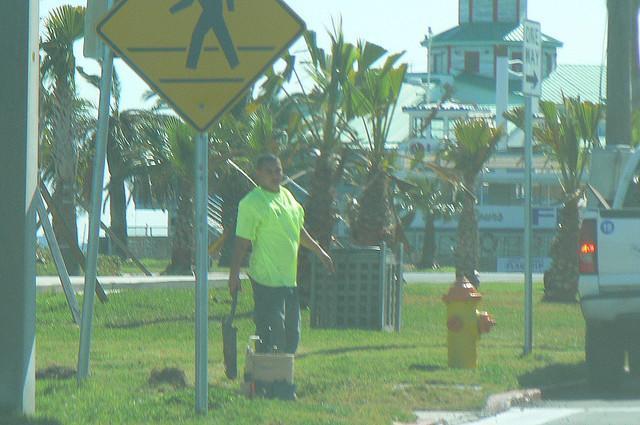How many trucks are there?
Give a very brief answer. 1. 